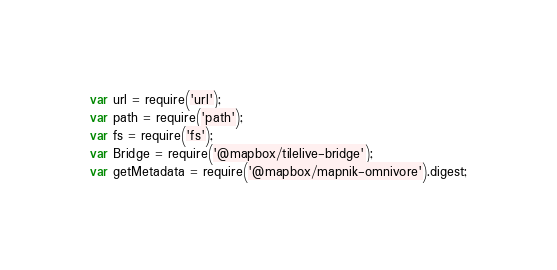Convert code to text. <code><loc_0><loc_0><loc_500><loc_500><_JavaScript_>var url = require('url');
var path = require('path');
var fs = require('fs');
var Bridge = require('@mapbox/tilelive-bridge');
var getMetadata = require('@mapbox/mapnik-omnivore').digest;</code> 